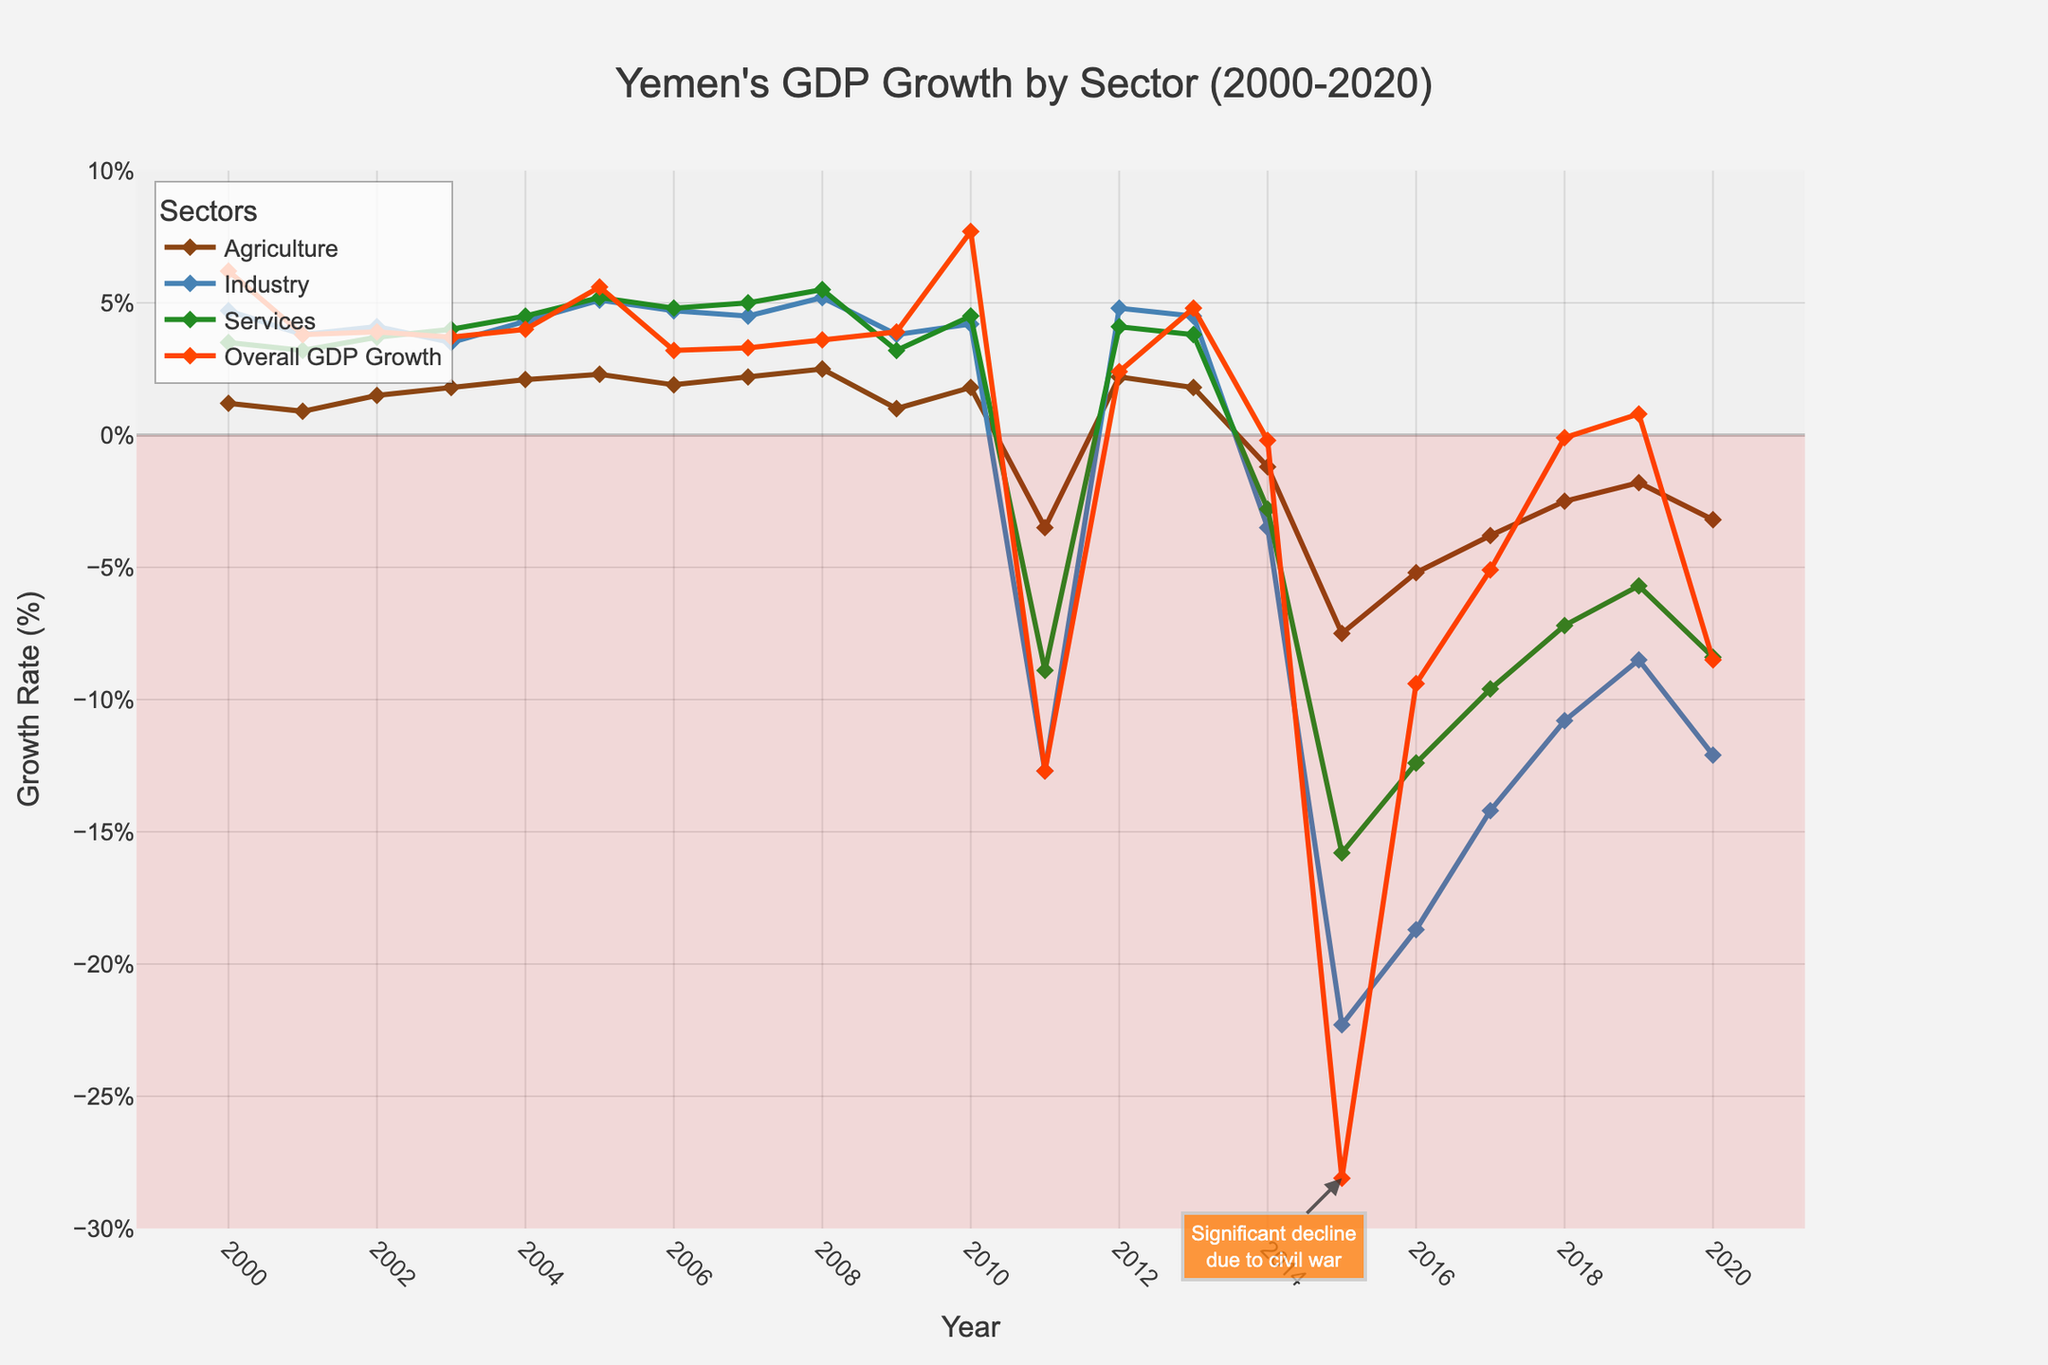What is the general trend in Yemen's Overall GDP Growth from 2000 to 2020? Looking at the line for "Overall GDP Growth," we can see there are periods of growth (2000-2010) followed by a significant decline starting in 2011, particularly with the sharpest decline around 2015 which is then followed by a slow recovery and fluctuations.
Answer: General growth until 2010, then a significant decline and fluctuations Which year shows the highest overall GDP growth rate? Referring to the "Overall GDP Growth" trace, the highest peak is in 2010, reaching 7.7%.
Answer: 2010 How did the Agriculture sector perform in 2015 compared to 2014? The Agriculture sector experienced a sharp decline in 2015 with a growth rate of -7.5%, compared to -1.2% in 2014.
Answer: Declined from -1.2% to -7.5% What is the difference in Industrial growth between 2005 and 2010? The Industrial growth rate for 2005 is 5.1%, and it is 4.2% for 2010. The difference is 5.1% - 4.2% = 0.9%.
Answer: 0.9% What are the years with negative growth rates across all sectors? Checking the segments where all sectors' lines drop below zero, these years are 2011, 2014, 2015, 2016, 2017, 2018, 2020.
Answer: 2011, 2014, 2015, 2016, 2017, 2018, 2020 How do the services sector growth rate in 2010 and 2020 compare visually? Visually, the growth rate of the Services sector is higher in 2010 (4.5%) and significantly lower in 2020 (-8.4%).
Answer: Higher in 2010, significantly lower in 2020 What is the average growth rate for the Industry sector from 2000 to 2010? Summing up the Industry growth rates from 2000 to 2010 [(4.7+3.8+4.1+3.5+4.3+5.1+4.7+4.5+5.2+3.8+4.2)=48.9] and dividing by the number of years (11), the average rate = 48.9/11 ≈ 4.45%.
Answer: 4.45% Which sector shows the most variability over the years? By examining the fluctuations in the lines, it is evident that the Industry sector has larger and more frequent changes in growth rates year over year compared to Agriculture and Services.
Answer: Industry What sector experienced the sharpest decline during 2011, and what was its value? The Industrial sector exhibits the sharpest decline in 2011 with a growth rate of -12.7%.
Answer: Industry, -12.7% In which years did the Services sector outperform the Overall GDP Growth? Comparing both lines, Services outperformed Overall GDP Growth in 2001, 2002, 2003, 2004, and 2006.
Answer: 2001, 2002, 2003, 2004, 2006 